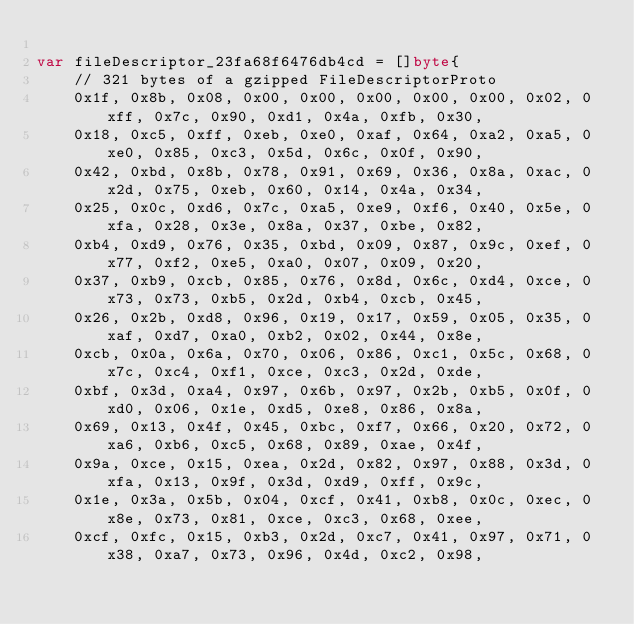Convert code to text. <code><loc_0><loc_0><loc_500><loc_500><_Go_>
var fileDescriptor_23fa68f6476db4cd = []byte{
	// 321 bytes of a gzipped FileDescriptorProto
	0x1f, 0x8b, 0x08, 0x00, 0x00, 0x00, 0x00, 0x00, 0x02, 0xff, 0x7c, 0x90, 0xd1, 0x4a, 0xfb, 0x30,
	0x18, 0xc5, 0xff, 0xeb, 0xe0, 0xaf, 0x64, 0xa2, 0xa5, 0xe0, 0x85, 0xc3, 0x5d, 0x6c, 0x0f, 0x90,
	0x42, 0xbd, 0x8b, 0x78, 0x91, 0x69, 0x36, 0x8a, 0xac, 0x2d, 0x75, 0xeb, 0x60, 0x14, 0x4a, 0x34,
	0x25, 0x0c, 0xd6, 0x7c, 0xa5, 0xe9, 0xf6, 0x40, 0x5e, 0xfa, 0x28, 0x3e, 0x8a, 0x37, 0xbe, 0x82,
	0xb4, 0xd9, 0x76, 0x35, 0xbd, 0x09, 0x87, 0x9c, 0xef, 0x77, 0xf2, 0xe5, 0xa0, 0x07, 0x09, 0x20,
	0x37, 0xb9, 0xcb, 0x85, 0x76, 0x8d, 0x6c, 0xd4, 0xce, 0x73, 0x73, 0xb5, 0x2d, 0xb4, 0xcb, 0x45,
	0x26, 0x2b, 0xd8, 0x96, 0x19, 0x17, 0x59, 0x05, 0x35, 0xaf, 0xd7, 0xa0, 0xb2, 0x02, 0x44, 0x8e,
	0xcb, 0x0a, 0x6a, 0x70, 0x06, 0x86, 0xc1, 0x5c, 0x68, 0x7c, 0xc4, 0xf1, 0xce, 0xc3, 0x2d, 0xde,
	0xbf, 0x3d, 0xa4, 0x97, 0x6b, 0x97, 0x2b, 0xb5, 0x0f, 0xd0, 0x06, 0x1e, 0xd5, 0xe8, 0x86, 0x8a,
	0x69, 0x13, 0x4f, 0x45, 0xbc, 0xf7, 0x66, 0x20, 0x72, 0xa6, 0xb6, 0xc5, 0x68, 0x89, 0xae, 0x4f,
	0x9a, 0xce, 0x15, 0xea, 0x2d, 0x82, 0x97, 0x88, 0x3d, 0xfa, 0x13, 0x9f, 0x3d, 0xd9, 0xff, 0x9c,
	0x1e, 0x3a, 0x5b, 0x04, 0xcf, 0x41, 0xb8, 0x0c, 0xec, 0x8e, 0x73, 0x81, 0xce, 0xc3, 0x68, 0xee,
	0xcf, 0xfc, 0x15, 0xb3, 0x2d, 0xc7, 0x41, 0x97, 0x71, 0x38, 0xa7, 0x73, 0x96, 0x4d, 0xc2, 0x98,</code> 